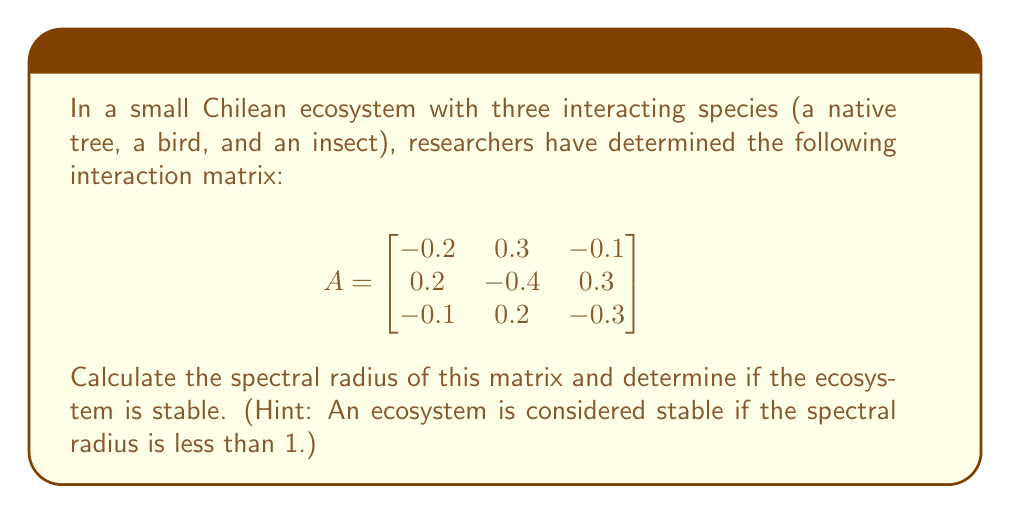What is the answer to this math problem? To solve this problem, we'll follow these steps:

1) First, we need to find the eigenvalues of the matrix A. The characteristic equation is:

   $$det(A - \lambda I) = 0$$

2) Expanding this:

   $$\begin{vmatrix}
   -0.2-\lambda & 0.3 & -0.1 \\
   0.2 & -0.4-\lambda & 0.3 \\
   -0.1 & 0.2 & -0.3-\lambda
   \end{vmatrix} = 0$$

3) This gives us the cubic equation:

   $$-\lambda^3 - 0.9\lambda^2 - 0.23\lambda - 0.014 = 0$$

4) Solving this equation (using a calculator or computer algebra system) gives us the eigenvalues:

   $$\lambda_1 \approx -0.7302, \lambda_2 \approx -0.0849 + 0.2775i, \lambda_3 \approx -0.0849 - 0.2775i$$

5) The spectral radius is the maximum absolute value of the eigenvalues:

   $$\rho(A) = \max(|\lambda_1|, |\lambda_2|, |\lambda_3|)$$

6) Calculate the absolute values:

   $$|\lambda_1| \approx 0.7302$$
   $$|\lambda_2| = |\lambda_3| = \sqrt{0.0849^2 + 0.2775^2} \approx 0.2902$$

7) The maximum of these is 0.7302, so the spectral radius is approximately 0.7302.

8) Since 0.7302 < 1, the ecosystem is stable.
Answer: Spectral radius ≈ 0.7302; ecosystem is stable. 